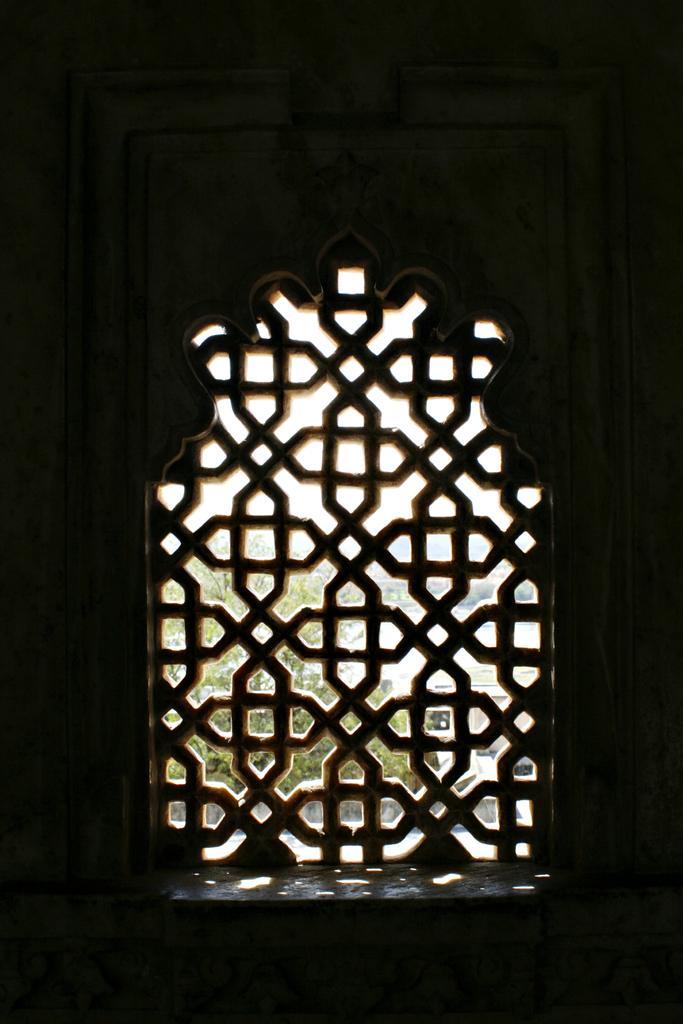Could you give a brief overview of what you see in this image? This is an inside view. Here I can see a window to the wall. Through the window we can see the outside view. In the outside view, I can see a tree and buildings. 